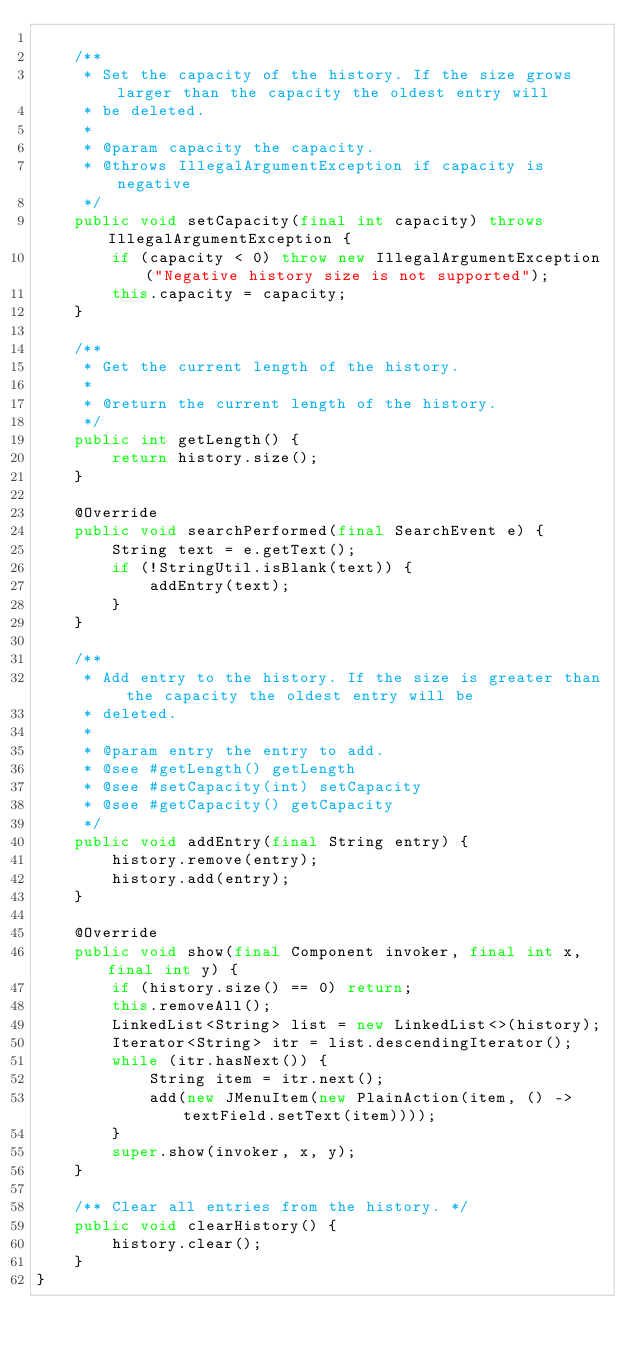<code> <loc_0><loc_0><loc_500><loc_500><_Java_>
    /**
     * Set the capacity of the history. If the size grows larger than the capacity the oldest entry will
     * be deleted.
     *
     * @param capacity the capacity.
     * @throws IllegalArgumentException if capacity is negative
     */
    public void setCapacity(final int capacity) throws IllegalArgumentException {
        if (capacity < 0) throw new IllegalArgumentException("Negative history size is not supported");
        this.capacity = capacity;
    }

    /**
     * Get the current length of the history.
     *
     * @return the current length of the history.
     */
    public int getLength() {
        return history.size();
    }

    @Override
    public void searchPerformed(final SearchEvent e) {
        String text = e.getText();
        if (!StringUtil.isBlank(text)) {
            addEntry(text);
        }
    }

    /**
     * Add entry to the history. If the size is greater than the capacity the oldest entry will be
     * deleted.
     *
     * @param entry the entry to add.
     * @see #getLength() getLength
     * @see #setCapacity(int) setCapacity
     * @see #getCapacity() getCapacity
     */
    public void addEntry(final String entry) {
        history.remove(entry);
        history.add(entry);
    }

    @Override
    public void show(final Component invoker, final int x, final int y) {
        if (history.size() == 0) return;
        this.removeAll();
        LinkedList<String> list = new LinkedList<>(history);
        Iterator<String> itr = list.descendingIterator();
        while (itr.hasNext()) {
            String item = itr.next();
            add(new JMenuItem(new PlainAction(item, () -> textField.setText(item))));
        }
        super.show(invoker, x, y);
    }

    /** Clear all entries from the history. */
    public void clearHistory() {
        history.clear();
    }
}
</code> 